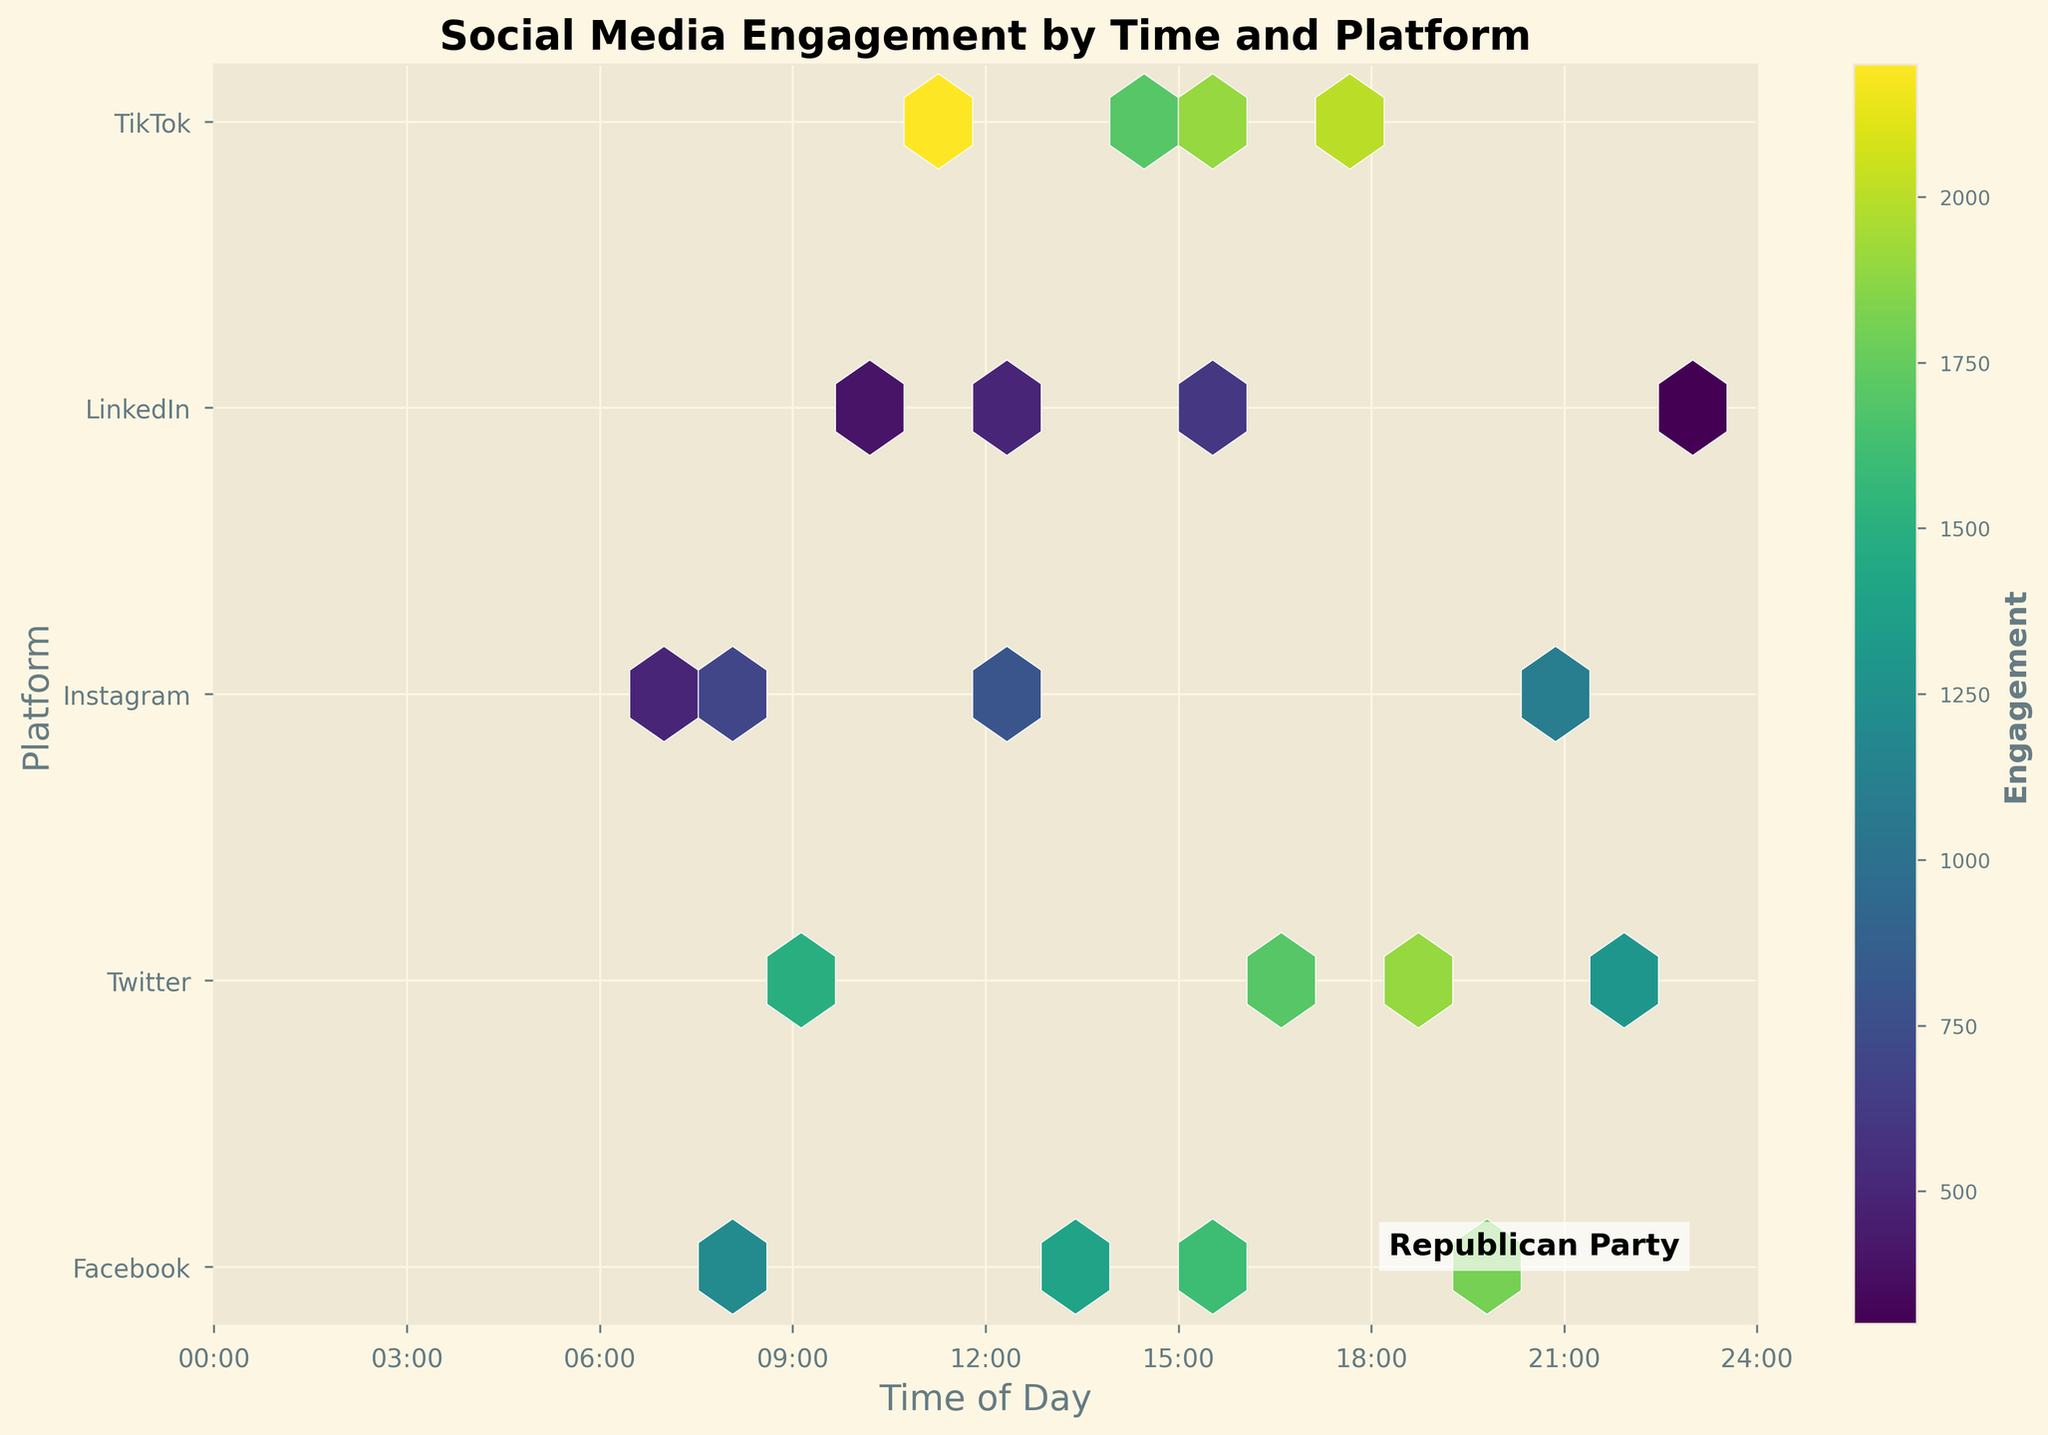What's the title of the figure? The title of the figure is usually found at the top of the plot. It provides a brief description of what the figure represents. In this case, the title is "Social Media Engagement by Time and Platform".
Answer: Social Media Engagement by Time and Platform What does the color intensity in the hexagons represent? The color intensity in the hexagons represents the engagement levels with social media content. Darker colors indicate higher engagement, while lighter colors show lower engagement.
Answer: Engagement levels How many platforms are represented in the dataset? The y-axis labels on the hexbin plot show the names of the platforms. Counting these labels gives the total number of platforms. In this figure, we have labels for Facebook, Twitter, Instagram, LinkedIn, and TikTok, making up 5 platforms.
Answer: 5 At what time of day do TikTok posts tend to get the highest engagement? By looking at the distribution of hexagons on the y-axis corresponding to TikTok, we can find the time range with the darkest color intensity. According to the figure, the darkest hexagons for TikTok are around the times 11:00 and 15:30.
Answer: 11:00 and 15:30 Which platform has the lowest overall engagement based on the hexbin plot? To answer this, observe which platform has the lightest colored hexagons overall in the figure. The platform with the most light-colored hexagons indicating low engagement is LinkedIn.
Answer: LinkedIn What is the general trend in engagement through the day for Facebook posts? Looking at the hexagons corresponding to Facebook across different times, observe the change in color intensity. Facebook posts have darker hexagons (indicating higher engagement) mainly in the evening from around 16:00 to 20:00.
Answer: Higher in the evening Compare the engagement levels of Twitter and Instagram between 9:00 to 12:00. Which has higher engagement? First, identify the hexagons for Twitter and Instagram between 9:00 to 12:00 on the x-axis. Compare the color intensity of the hexagons. Twitter's hexagons are darker than those of Instagram within this time frame, indicating higher engagement.
Answer: Twitter On which platform is there a significant spike in engagement in the afternoon? Look for the platform which has a particularly dark hexagon or cluster of hexagons in the afternoon hours (after 12:00). TikTok shows a significant spike in engagement around 15:30.
Answer: TikTok Considering Facebook and Twitter, at which specific time do they both register high engagement levels in the evening? Identify overlapping dark hexagons for both Facebook and Twitter in the evening hours. Both platforms show high engagement at 19:00 for Twitter.
Answer: 19:00 How does the engagement on TikTok at 18:00 compare to Facebook at 20:00? Compare the color intensity of the hexagon for TikTok around 18:00 with the hexagon for Facebook around 20:00. Both hexagons are very dark, which means they have high engagement, but TikTok is slightly darker at 18:00.
Answer: TikTok is higher at 18:00 